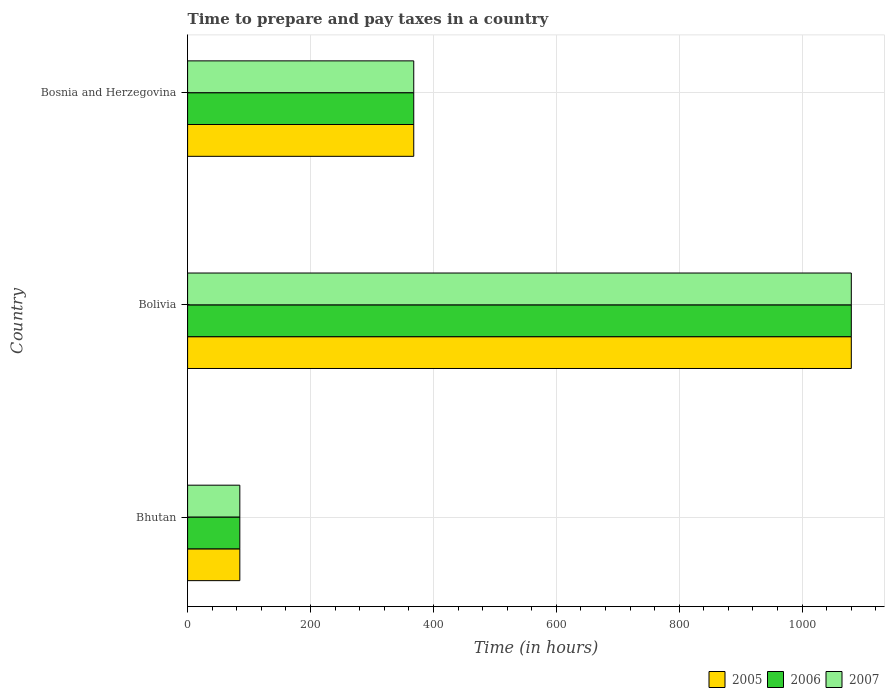How many different coloured bars are there?
Keep it short and to the point. 3. How many groups of bars are there?
Your answer should be compact. 3. Are the number of bars on each tick of the Y-axis equal?
Your answer should be very brief. Yes. How many bars are there on the 1st tick from the bottom?
Your response must be concise. 3. What is the label of the 2nd group of bars from the top?
Make the answer very short. Bolivia. What is the number of hours required to prepare and pay taxes in 2005 in Bhutan?
Provide a succinct answer. 85. Across all countries, what is the maximum number of hours required to prepare and pay taxes in 2006?
Your answer should be very brief. 1080. Across all countries, what is the minimum number of hours required to prepare and pay taxes in 2005?
Your answer should be compact. 85. In which country was the number of hours required to prepare and pay taxes in 2007 minimum?
Provide a succinct answer. Bhutan. What is the total number of hours required to prepare and pay taxes in 2007 in the graph?
Your response must be concise. 1533. What is the difference between the number of hours required to prepare and pay taxes in 2006 in Bhutan and that in Bosnia and Herzegovina?
Ensure brevity in your answer.  -283. What is the difference between the number of hours required to prepare and pay taxes in 2005 in Bolivia and the number of hours required to prepare and pay taxes in 2006 in Bosnia and Herzegovina?
Your answer should be compact. 712. What is the average number of hours required to prepare and pay taxes in 2007 per country?
Give a very brief answer. 511. What is the difference between the number of hours required to prepare and pay taxes in 2006 and number of hours required to prepare and pay taxes in 2005 in Bhutan?
Make the answer very short. 0. What is the ratio of the number of hours required to prepare and pay taxes in 2007 in Bolivia to that in Bosnia and Herzegovina?
Make the answer very short. 2.93. Is the difference between the number of hours required to prepare and pay taxes in 2006 in Bolivia and Bosnia and Herzegovina greater than the difference between the number of hours required to prepare and pay taxes in 2005 in Bolivia and Bosnia and Herzegovina?
Make the answer very short. No. What is the difference between the highest and the second highest number of hours required to prepare and pay taxes in 2005?
Give a very brief answer. 712. What is the difference between the highest and the lowest number of hours required to prepare and pay taxes in 2007?
Keep it short and to the point. 995. Are all the bars in the graph horizontal?
Give a very brief answer. Yes. What is the difference between two consecutive major ticks on the X-axis?
Make the answer very short. 200. Where does the legend appear in the graph?
Your response must be concise. Bottom right. What is the title of the graph?
Ensure brevity in your answer.  Time to prepare and pay taxes in a country. What is the label or title of the X-axis?
Your answer should be compact. Time (in hours). What is the Time (in hours) of 2005 in Bolivia?
Give a very brief answer. 1080. What is the Time (in hours) of 2006 in Bolivia?
Provide a short and direct response. 1080. What is the Time (in hours) in 2007 in Bolivia?
Your answer should be very brief. 1080. What is the Time (in hours) of 2005 in Bosnia and Herzegovina?
Keep it short and to the point. 368. What is the Time (in hours) of 2006 in Bosnia and Herzegovina?
Ensure brevity in your answer.  368. What is the Time (in hours) of 2007 in Bosnia and Herzegovina?
Make the answer very short. 368. Across all countries, what is the maximum Time (in hours) of 2005?
Provide a succinct answer. 1080. Across all countries, what is the maximum Time (in hours) in 2006?
Your answer should be compact. 1080. Across all countries, what is the maximum Time (in hours) in 2007?
Provide a short and direct response. 1080. Across all countries, what is the minimum Time (in hours) of 2006?
Ensure brevity in your answer.  85. Across all countries, what is the minimum Time (in hours) of 2007?
Offer a very short reply. 85. What is the total Time (in hours) in 2005 in the graph?
Offer a terse response. 1533. What is the total Time (in hours) of 2006 in the graph?
Offer a very short reply. 1533. What is the total Time (in hours) in 2007 in the graph?
Give a very brief answer. 1533. What is the difference between the Time (in hours) in 2005 in Bhutan and that in Bolivia?
Your response must be concise. -995. What is the difference between the Time (in hours) of 2006 in Bhutan and that in Bolivia?
Your answer should be very brief. -995. What is the difference between the Time (in hours) in 2007 in Bhutan and that in Bolivia?
Offer a terse response. -995. What is the difference between the Time (in hours) in 2005 in Bhutan and that in Bosnia and Herzegovina?
Your response must be concise. -283. What is the difference between the Time (in hours) of 2006 in Bhutan and that in Bosnia and Herzegovina?
Your answer should be very brief. -283. What is the difference between the Time (in hours) of 2007 in Bhutan and that in Bosnia and Herzegovina?
Make the answer very short. -283. What is the difference between the Time (in hours) of 2005 in Bolivia and that in Bosnia and Herzegovina?
Give a very brief answer. 712. What is the difference between the Time (in hours) of 2006 in Bolivia and that in Bosnia and Herzegovina?
Make the answer very short. 712. What is the difference between the Time (in hours) of 2007 in Bolivia and that in Bosnia and Herzegovina?
Provide a succinct answer. 712. What is the difference between the Time (in hours) of 2005 in Bhutan and the Time (in hours) of 2006 in Bolivia?
Ensure brevity in your answer.  -995. What is the difference between the Time (in hours) of 2005 in Bhutan and the Time (in hours) of 2007 in Bolivia?
Give a very brief answer. -995. What is the difference between the Time (in hours) of 2006 in Bhutan and the Time (in hours) of 2007 in Bolivia?
Ensure brevity in your answer.  -995. What is the difference between the Time (in hours) of 2005 in Bhutan and the Time (in hours) of 2006 in Bosnia and Herzegovina?
Your response must be concise. -283. What is the difference between the Time (in hours) of 2005 in Bhutan and the Time (in hours) of 2007 in Bosnia and Herzegovina?
Keep it short and to the point. -283. What is the difference between the Time (in hours) in 2006 in Bhutan and the Time (in hours) in 2007 in Bosnia and Herzegovina?
Offer a very short reply. -283. What is the difference between the Time (in hours) of 2005 in Bolivia and the Time (in hours) of 2006 in Bosnia and Herzegovina?
Your answer should be very brief. 712. What is the difference between the Time (in hours) in 2005 in Bolivia and the Time (in hours) in 2007 in Bosnia and Herzegovina?
Offer a terse response. 712. What is the difference between the Time (in hours) in 2006 in Bolivia and the Time (in hours) in 2007 in Bosnia and Herzegovina?
Give a very brief answer. 712. What is the average Time (in hours) in 2005 per country?
Offer a very short reply. 511. What is the average Time (in hours) of 2006 per country?
Give a very brief answer. 511. What is the average Time (in hours) of 2007 per country?
Keep it short and to the point. 511. What is the difference between the Time (in hours) of 2005 and Time (in hours) of 2007 in Bhutan?
Provide a succinct answer. 0. What is the difference between the Time (in hours) of 2006 and Time (in hours) of 2007 in Bhutan?
Your answer should be compact. 0. What is the difference between the Time (in hours) in 2005 and Time (in hours) in 2006 in Bolivia?
Provide a succinct answer. 0. What is the difference between the Time (in hours) of 2005 and Time (in hours) of 2007 in Bolivia?
Ensure brevity in your answer.  0. What is the difference between the Time (in hours) of 2006 and Time (in hours) of 2007 in Bolivia?
Provide a succinct answer. 0. What is the difference between the Time (in hours) of 2005 and Time (in hours) of 2007 in Bosnia and Herzegovina?
Give a very brief answer. 0. What is the difference between the Time (in hours) of 2006 and Time (in hours) of 2007 in Bosnia and Herzegovina?
Offer a terse response. 0. What is the ratio of the Time (in hours) in 2005 in Bhutan to that in Bolivia?
Ensure brevity in your answer.  0.08. What is the ratio of the Time (in hours) of 2006 in Bhutan to that in Bolivia?
Your answer should be compact. 0.08. What is the ratio of the Time (in hours) of 2007 in Bhutan to that in Bolivia?
Make the answer very short. 0.08. What is the ratio of the Time (in hours) in 2005 in Bhutan to that in Bosnia and Herzegovina?
Offer a very short reply. 0.23. What is the ratio of the Time (in hours) of 2006 in Bhutan to that in Bosnia and Herzegovina?
Give a very brief answer. 0.23. What is the ratio of the Time (in hours) in 2007 in Bhutan to that in Bosnia and Herzegovina?
Make the answer very short. 0.23. What is the ratio of the Time (in hours) in 2005 in Bolivia to that in Bosnia and Herzegovina?
Ensure brevity in your answer.  2.93. What is the ratio of the Time (in hours) in 2006 in Bolivia to that in Bosnia and Herzegovina?
Make the answer very short. 2.93. What is the ratio of the Time (in hours) of 2007 in Bolivia to that in Bosnia and Herzegovina?
Provide a succinct answer. 2.93. What is the difference between the highest and the second highest Time (in hours) of 2005?
Ensure brevity in your answer.  712. What is the difference between the highest and the second highest Time (in hours) in 2006?
Offer a very short reply. 712. What is the difference between the highest and the second highest Time (in hours) in 2007?
Keep it short and to the point. 712. What is the difference between the highest and the lowest Time (in hours) of 2005?
Ensure brevity in your answer.  995. What is the difference between the highest and the lowest Time (in hours) of 2006?
Keep it short and to the point. 995. What is the difference between the highest and the lowest Time (in hours) in 2007?
Keep it short and to the point. 995. 